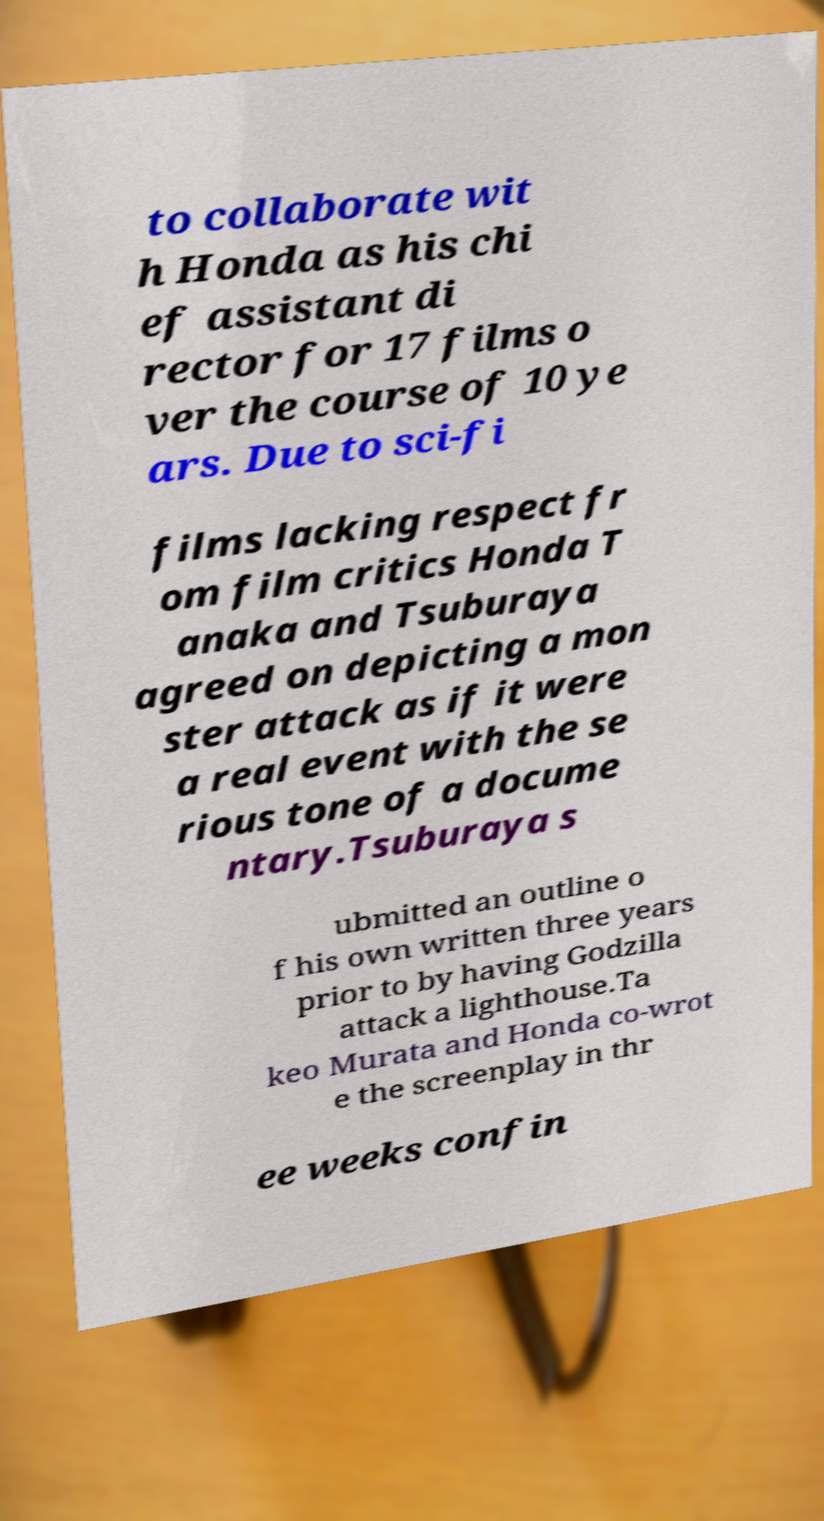Can you accurately transcribe the text from the provided image for me? to collaborate wit h Honda as his chi ef assistant di rector for 17 films o ver the course of 10 ye ars. Due to sci-fi films lacking respect fr om film critics Honda T anaka and Tsuburaya agreed on depicting a mon ster attack as if it were a real event with the se rious tone of a docume ntary.Tsuburaya s ubmitted an outline o f his own written three years prior to by having Godzilla attack a lighthouse.Ta keo Murata and Honda co-wrot e the screenplay in thr ee weeks confin 